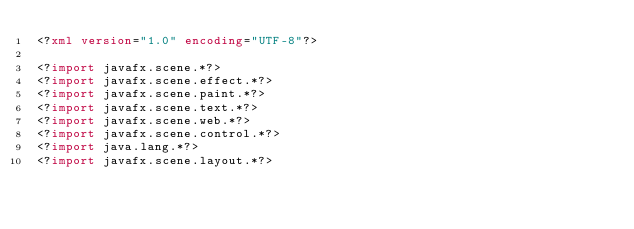<code> <loc_0><loc_0><loc_500><loc_500><_XML_><?xml version="1.0" encoding="UTF-8"?>

<?import javafx.scene.*?>
<?import javafx.scene.effect.*?>
<?import javafx.scene.paint.*?>
<?import javafx.scene.text.*?>
<?import javafx.scene.web.*?>
<?import javafx.scene.control.*?>
<?import java.lang.*?>
<?import javafx.scene.layout.*?></code> 